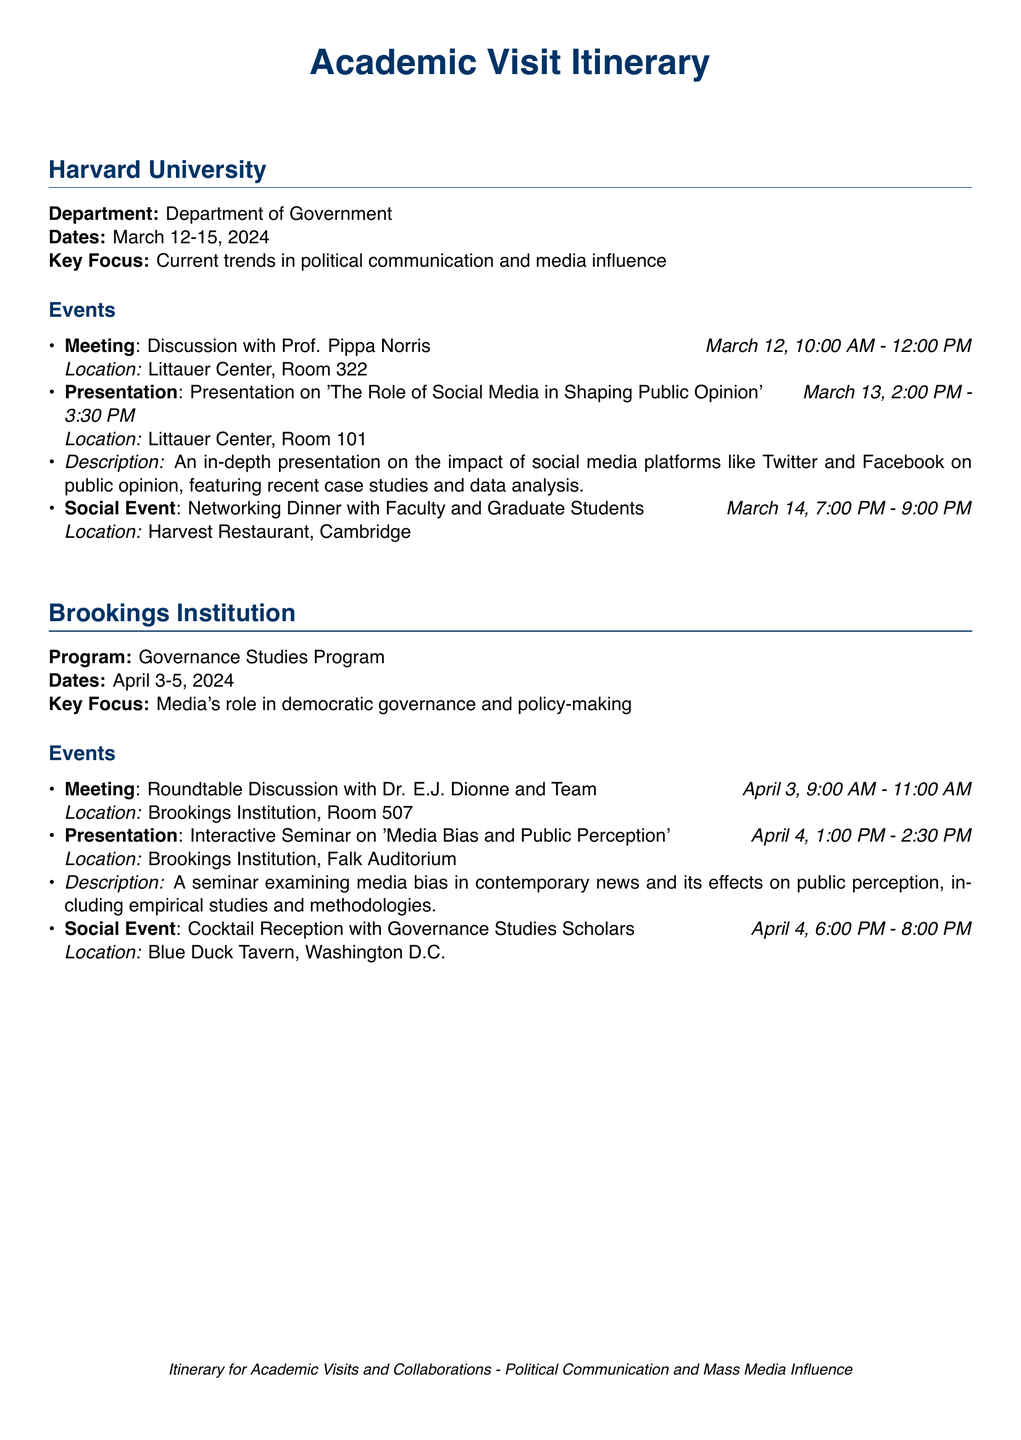What are the dates of the visit to Harvard University? The dates of the visit to Harvard University are specified in the document.
Answer: March 12-15, 2024 Who is the main contact at Brookings Institution? The main contact for discussions at Brookings Institution is mentioned.
Answer: Dr. E.J. Dionne What is the key focus of the visit to Harvard University? The document outlines the key focus of the visit, detailing the area of study.
Answer: Current trends in political communication and media influence What time does the presentation on social media take place? The time for the specific presentation at Harvard University is noted in the itinerary.
Answer: March 13, 2:00 PM - 3:30 PM How many social events are scheduled during the visits? The total number of scheduled social events can be calculated from each university visit's itinerary.
Answer: 2 What is the location of the cocktail reception at Brookings Institution? The location for the cocktail reception is stated in the document.
Answer: Blue Duck Tavern, Washington D.C What is the description of the seminar at Brookings Institution? The document includes a brief description of the seminar's content and focus.
Answer: A seminar examining media bias in contemporary news and its effects on public perception, including empirical studies and methodologies What is the general theme of the itinerary? The overall theme is highlighted at the bottom of the document.
Answer: Political Communication and Mass Media Influence 